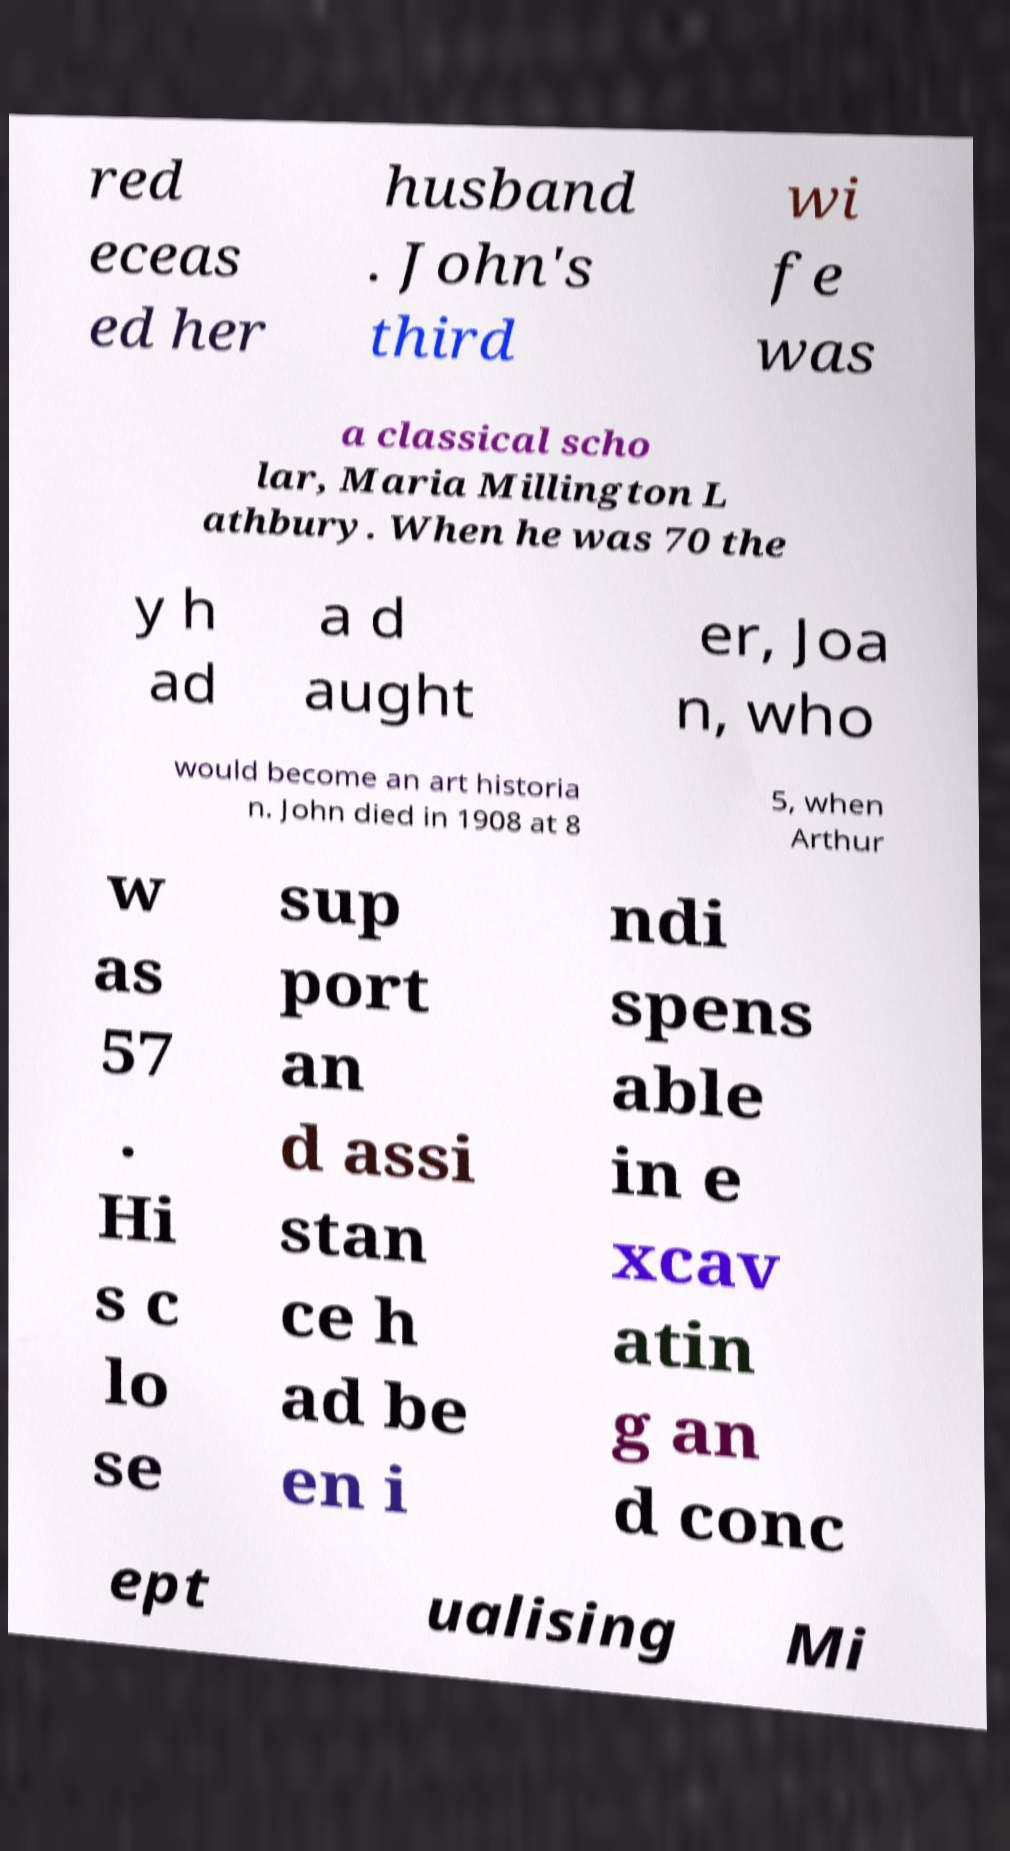What messages or text are displayed in this image? I need them in a readable, typed format. red eceas ed her husband . John's third wi fe was a classical scho lar, Maria Millington L athbury. When he was 70 the y h ad a d aught er, Joa n, who would become an art historia n. John died in 1908 at 8 5, when Arthur w as 57 . Hi s c lo se sup port an d assi stan ce h ad be en i ndi spens able in e xcav atin g an d conc ept ualising Mi 